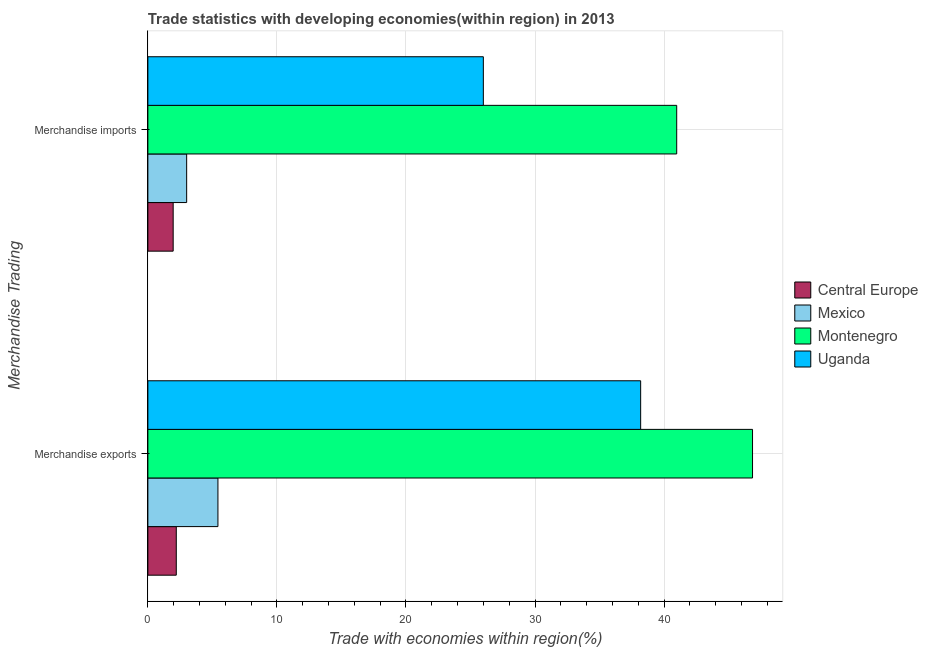How many different coloured bars are there?
Ensure brevity in your answer.  4. How many groups of bars are there?
Keep it short and to the point. 2. Are the number of bars on each tick of the Y-axis equal?
Offer a very short reply. Yes. How many bars are there on the 2nd tick from the top?
Provide a short and direct response. 4. How many bars are there on the 1st tick from the bottom?
Your answer should be compact. 4. What is the merchandise exports in Uganda?
Keep it short and to the point. 38.18. Across all countries, what is the maximum merchandise imports?
Your response must be concise. 40.98. Across all countries, what is the minimum merchandise exports?
Ensure brevity in your answer.  2.2. In which country was the merchandise exports maximum?
Provide a succinct answer. Montenegro. In which country was the merchandise exports minimum?
Keep it short and to the point. Central Europe. What is the total merchandise imports in the graph?
Your answer should be very brief. 71.94. What is the difference between the merchandise exports in Central Europe and that in Mexico?
Give a very brief answer. -3.23. What is the difference between the merchandise exports in Central Europe and the merchandise imports in Uganda?
Your answer should be very brief. -23.79. What is the average merchandise exports per country?
Offer a terse response. 23.17. What is the difference between the merchandise exports and merchandise imports in Mexico?
Offer a very short reply. 2.42. What is the ratio of the merchandise imports in Uganda to that in Central Europe?
Make the answer very short. 13.26. In how many countries, is the merchandise exports greater than the average merchandise exports taken over all countries?
Your answer should be very brief. 2. What does the 2nd bar from the top in Merchandise exports represents?
Offer a very short reply. Montenegro. What does the 1st bar from the bottom in Merchandise exports represents?
Your response must be concise. Central Europe. How many bars are there?
Offer a terse response. 8. Are all the bars in the graph horizontal?
Provide a succinct answer. Yes. How many countries are there in the graph?
Ensure brevity in your answer.  4. What is the difference between two consecutive major ticks on the X-axis?
Make the answer very short. 10. Are the values on the major ticks of X-axis written in scientific E-notation?
Your response must be concise. No. Does the graph contain any zero values?
Offer a very short reply. No. How many legend labels are there?
Keep it short and to the point. 4. How are the legend labels stacked?
Make the answer very short. Vertical. What is the title of the graph?
Make the answer very short. Trade statistics with developing economies(within region) in 2013. What is the label or title of the X-axis?
Provide a succinct answer. Trade with economies within region(%). What is the label or title of the Y-axis?
Your answer should be compact. Merchandise Trading. What is the Trade with economies within region(%) in Central Europe in Merchandise exports?
Your answer should be compact. 2.2. What is the Trade with economies within region(%) of Mexico in Merchandise exports?
Offer a terse response. 5.43. What is the Trade with economies within region(%) of Montenegro in Merchandise exports?
Make the answer very short. 46.85. What is the Trade with economies within region(%) in Uganda in Merchandise exports?
Offer a very short reply. 38.18. What is the Trade with economies within region(%) in Central Europe in Merchandise imports?
Ensure brevity in your answer.  1.96. What is the Trade with economies within region(%) in Mexico in Merchandise imports?
Your answer should be compact. 3.01. What is the Trade with economies within region(%) of Montenegro in Merchandise imports?
Make the answer very short. 40.98. What is the Trade with economies within region(%) of Uganda in Merchandise imports?
Your response must be concise. 25.99. Across all Merchandise Trading, what is the maximum Trade with economies within region(%) of Central Europe?
Your answer should be very brief. 2.2. Across all Merchandise Trading, what is the maximum Trade with economies within region(%) of Mexico?
Offer a terse response. 5.43. Across all Merchandise Trading, what is the maximum Trade with economies within region(%) of Montenegro?
Your answer should be very brief. 46.85. Across all Merchandise Trading, what is the maximum Trade with economies within region(%) in Uganda?
Offer a terse response. 38.18. Across all Merchandise Trading, what is the minimum Trade with economies within region(%) of Central Europe?
Provide a succinct answer. 1.96. Across all Merchandise Trading, what is the minimum Trade with economies within region(%) of Mexico?
Give a very brief answer. 3.01. Across all Merchandise Trading, what is the minimum Trade with economies within region(%) of Montenegro?
Offer a terse response. 40.98. Across all Merchandise Trading, what is the minimum Trade with economies within region(%) of Uganda?
Give a very brief answer. 25.99. What is the total Trade with economies within region(%) of Central Europe in the graph?
Provide a short and direct response. 4.16. What is the total Trade with economies within region(%) of Mexico in the graph?
Your response must be concise. 8.44. What is the total Trade with economies within region(%) of Montenegro in the graph?
Offer a terse response. 87.83. What is the total Trade with economies within region(%) in Uganda in the graph?
Give a very brief answer. 64.18. What is the difference between the Trade with economies within region(%) in Central Europe in Merchandise exports and that in Merchandise imports?
Give a very brief answer. 0.24. What is the difference between the Trade with economies within region(%) of Mexico in Merchandise exports and that in Merchandise imports?
Your answer should be compact. 2.42. What is the difference between the Trade with economies within region(%) of Montenegro in Merchandise exports and that in Merchandise imports?
Provide a succinct answer. 5.87. What is the difference between the Trade with economies within region(%) in Uganda in Merchandise exports and that in Merchandise imports?
Give a very brief answer. 12.19. What is the difference between the Trade with economies within region(%) in Central Europe in Merchandise exports and the Trade with economies within region(%) in Mexico in Merchandise imports?
Offer a very short reply. -0.8. What is the difference between the Trade with economies within region(%) of Central Europe in Merchandise exports and the Trade with economies within region(%) of Montenegro in Merchandise imports?
Give a very brief answer. -38.78. What is the difference between the Trade with economies within region(%) in Central Europe in Merchandise exports and the Trade with economies within region(%) in Uganda in Merchandise imports?
Offer a terse response. -23.79. What is the difference between the Trade with economies within region(%) in Mexico in Merchandise exports and the Trade with economies within region(%) in Montenegro in Merchandise imports?
Offer a terse response. -35.55. What is the difference between the Trade with economies within region(%) of Mexico in Merchandise exports and the Trade with economies within region(%) of Uganda in Merchandise imports?
Make the answer very short. -20.56. What is the difference between the Trade with economies within region(%) of Montenegro in Merchandise exports and the Trade with economies within region(%) of Uganda in Merchandise imports?
Offer a terse response. 20.86. What is the average Trade with economies within region(%) in Central Europe per Merchandise Trading?
Make the answer very short. 2.08. What is the average Trade with economies within region(%) of Mexico per Merchandise Trading?
Provide a succinct answer. 4.22. What is the average Trade with economies within region(%) of Montenegro per Merchandise Trading?
Your answer should be very brief. 43.91. What is the average Trade with economies within region(%) in Uganda per Merchandise Trading?
Make the answer very short. 32.09. What is the difference between the Trade with economies within region(%) of Central Europe and Trade with economies within region(%) of Mexico in Merchandise exports?
Provide a succinct answer. -3.23. What is the difference between the Trade with economies within region(%) of Central Europe and Trade with economies within region(%) of Montenegro in Merchandise exports?
Keep it short and to the point. -44.65. What is the difference between the Trade with economies within region(%) in Central Europe and Trade with economies within region(%) in Uganda in Merchandise exports?
Provide a succinct answer. -35.98. What is the difference between the Trade with economies within region(%) in Mexico and Trade with economies within region(%) in Montenegro in Merchandise exports?
Provide a succinct answer. -41.42. What is the difference between the Trade with economies within region(%) in Mexico and Trade with economies within region(%) in Uganda in Merchandise exports?
Ensure brevity in your answer.  -32.75. What is the difference between the Trade with economies within region(%) in Montenegro and Trade with economies within region(%) in Uganda in Merchandise exports?
Your response must be concise. 8.67. What is the difference between the Trade with economies within region(%) in Central Europe and Trade with economies within region(%) in Mexico in Merchandise imports?
Offer a very short reply. -1.04. What is the difference between the Trade with economies within region(%) of Central Europe and Trade with economies within region(%) of Montenegro in Merchandise imports?
Provide a succinct answer. -39.02. What is the difference between the Trade with economies within region(%) of Central Europe and Trade with economies within region(%) of Uganda in Merchandise imports?
Your response must be concise. -24.03. What is the difference between the Trade with economies within region(%) of Mexico and Trade with economies within region(%) of Montenegro in Merchandise imports?
Keep it short and to the point. -37.97. What is the difference between the Trade with economies within region(%) of Mexico and Trade with economies within region(%) of Uganda in Merchandise imports?
Your response must be concise. -22.99. What is the difference between the Trade with economies within region(%) in Montenegro and Trade with economies within region(%) in Uganda in Merchandise imports?
Ensure brevity in your answer.  14.98. What is the ratio of the Trade with economies within region(%) of Central Europe in Merchandise exports to that in Merchandise imports?
Give a very brief answer. 1.12. What is the ratio of the Trade with economies within region(%) in Mexico in Merchandise exports to that in Merchandise imports?
Your answer should be very brief. 1.81. What is the ratio of the Trade with economies within region(%) of Montenegro in Merchandise exports to that in Merchandise imports?
Keep it short and to the point. 1.14. What is the ratio of the Trade with economies within region(%) in Uganda in Merchandise exports to that in Merchandise imports?
Give a very brief answer. 1.47. What is the difference between the highest and the second highest Trade with economies within region(%) of Central Europe?
Make the answer very short. 0.24. What is the difference between the highest and the second highest Trade with economies within region(%) of Mexico?
Offer a very short reply. 2.42. What is the difference between the highest and the second highest Trade with economies within region(%) of Montenegro?
Keep it short and to the point. 5.87. What is the difference between the highest and the second highest Trade with economies within region(%) of Uganda?
Provide a succinct answer. 12.19. What is the difference between the highest and the lowest Trade with economies within region(%) in Central Europe?
Provide a succinct answer. 0.24. What is the difference between the highest and the lowest Trade with economies within region(%) of Mexico?
Offer a terse response. 2.42. What is the difference between the highest and the lowest Trade with economies within region(%) in Montenegro?
Provide a short and direct response. 5.87. What is the difference between the highest and the lowest Trade with economies within region(%) of Uganda?
Provide a short and direct response. 12.19. 